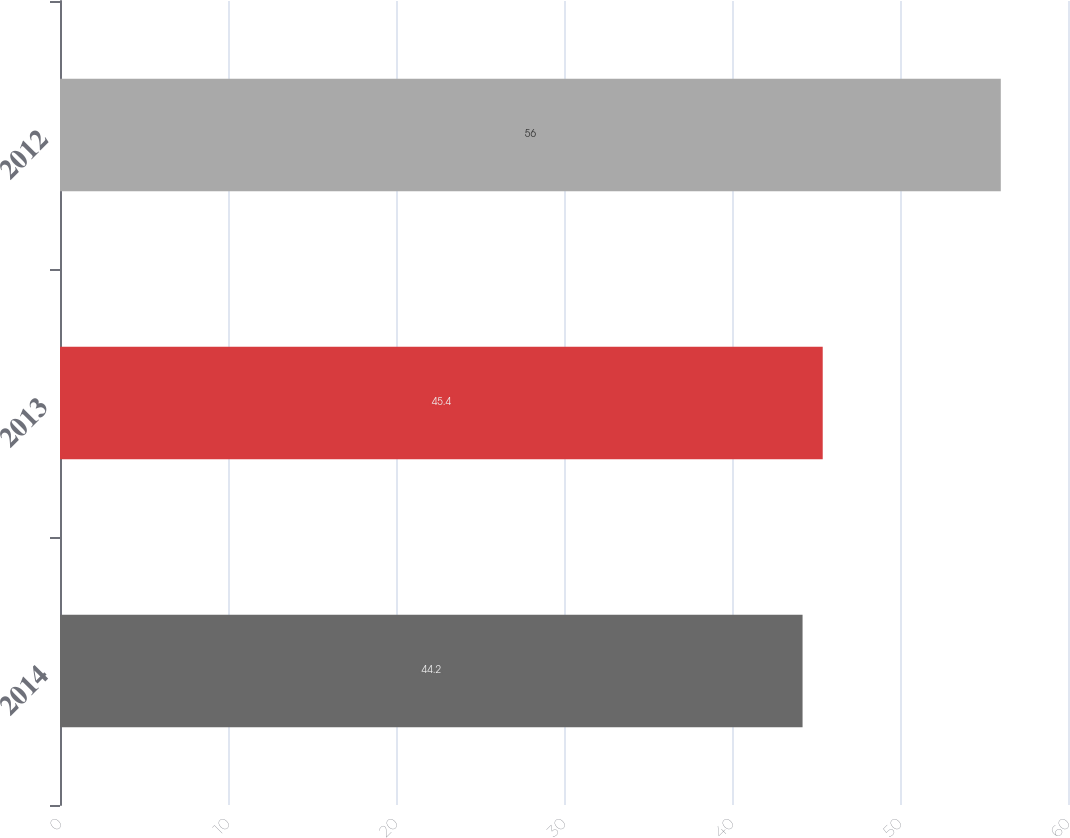<chart> <loc_0><loc_0><loc_500><loc_500><bar_chart><fcel>2014<fcel>2013<fcel>2012<nl><fcel>44.2<fcel>45.4<fcel>56<nl></chart> 